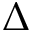Convert formula to latex. <formula><loc_0><loc_0><loc_500><loc_500>\Delta</formula> 